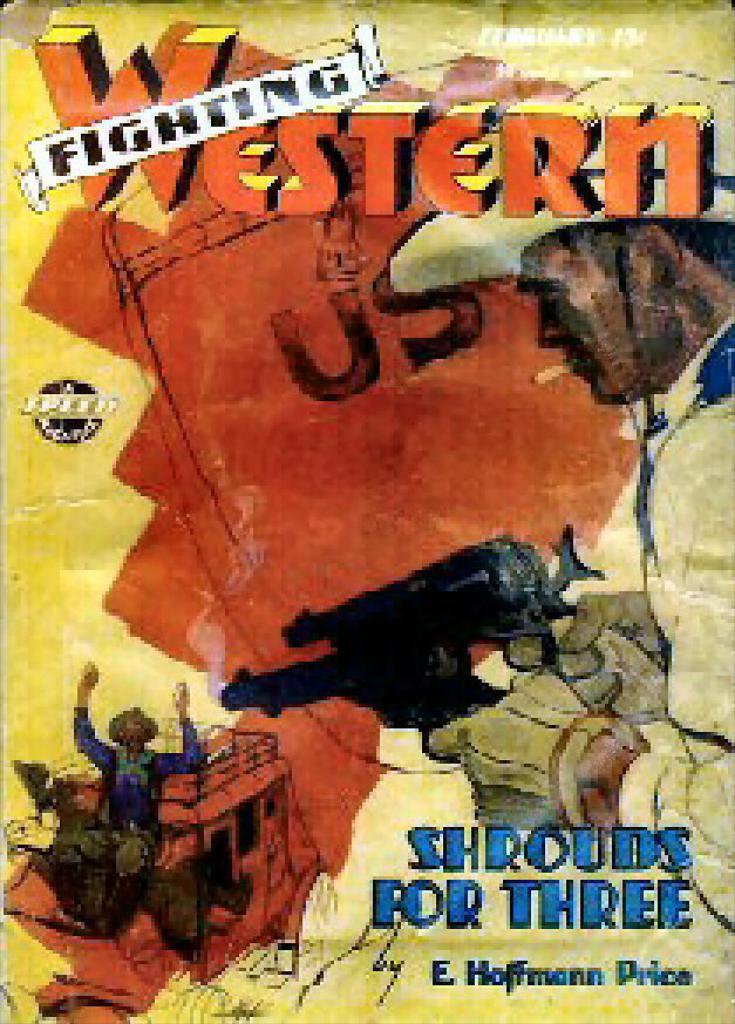The fighting what?
Make the answer very short. Western. Who is the creator of the comic?
Your response must be concise. E. hoffmann price. 